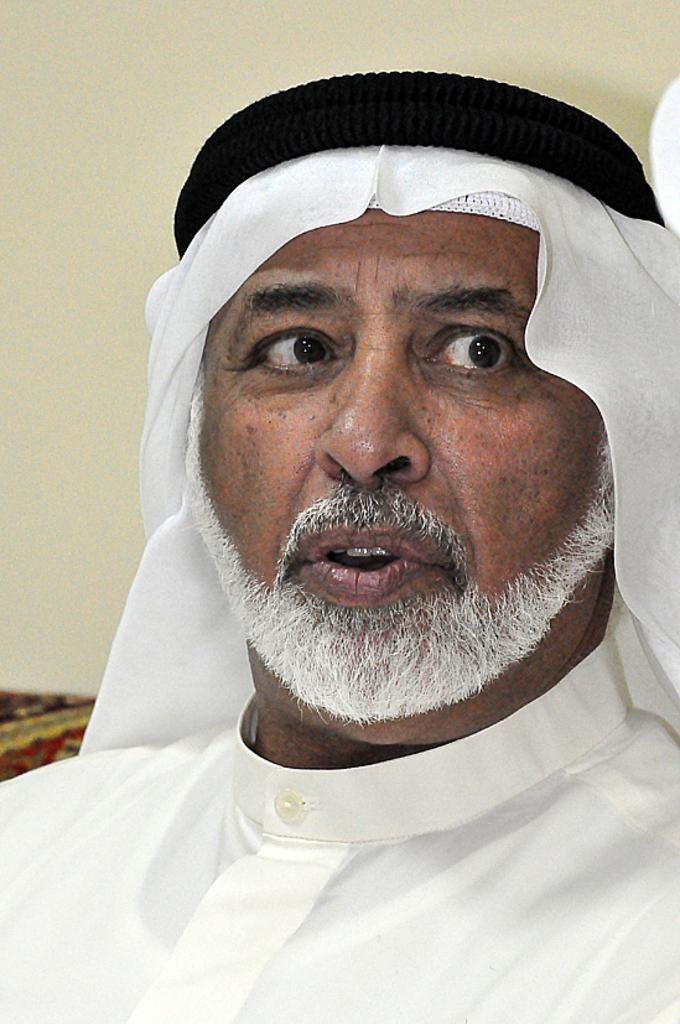Who or what is the main subject in the image? There is a person in the image. What color is the background of the image? The background of the image is yellow. What can be observed about the person's attire in the image? The person is wearing clothes. How many cherries are on the rose in the image? There is no rose or cherries present in the image. 